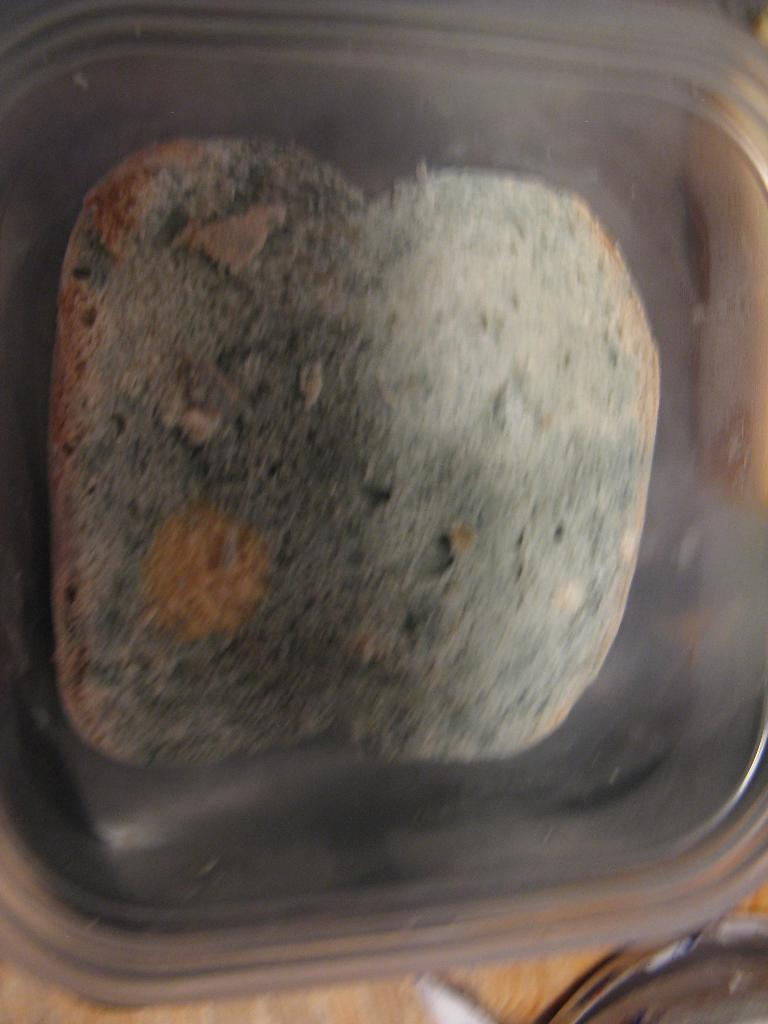What is located on a surface in the image? There is a bowl in the image. Can you describe the positioning of the bowl in the image? The bowl is placed on a surface. What type of underwear is the judge wearing in the image? There is no judge or underwear present in the image; it only features a bowl placed on a surface. 